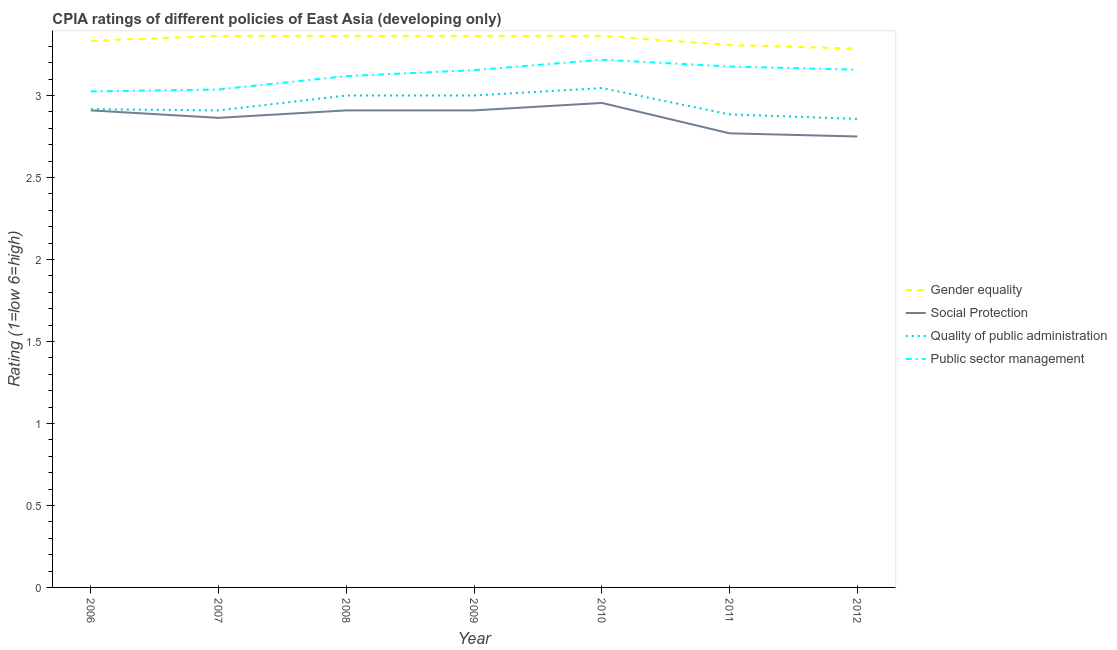Does the line corresponding to cpia rating of social protection intersect with the line corresponding to cpia rating of public sector management?
Your answer should be compact. No. Is the number of lines equal to the number of legend labels?
Your answer should be compact. Yes. What is the cpia rating of social protection in 2010?
Give a very brief answer. 2.95. Across all years, what is the maximum cpia rating of gender equality?
Offer a very short reply. 3.36. Across all years, what is the minimum cpia rating of social protection?
Provide a short and direct response. 2.75. What is the total cpia rating of public sector management in the graph?
Provide a succinct answer. 21.89. What is the difference between the cpia rating of public sector management in 2010 and that in 2012?
Your response must be concise. 0.06. What is the difference between the cpia rating of public sector management in 2006 and the cpia rating of quality of public administration in 2010?
Give a very brief answer. -0.02. What is the average cpia rating of social protection per year?
Make the answer very short. 2.87. In the year 2012, what is the difference between the cpia rating of public sector management and cpia rating of social protection?
Your response must be concise. 0.41. What is the ratio of the cpia rating of social protection in 2010 to that in 2012?
Your response must be concise. 1.07. What is the difference between the highest and the second highest cpia rating of quality of public administration?
Give a very brief answer. 0.05. What is the difference between the highest and the lowest cpia rating of gender equality?
Keep it short and to the point. 0.08. In how many years, is the cpia rating of gender equality greater than the average cpia rating of gender equality taken over all years?
Your response must be concise. 4. Is the sum of the cpia rating of gender equality in 2006 and 2010 greater than the maximum cpia rating of quality of public administration across all years?
Ensure brevity in your answer.  Yes. Is it the case that in every year, the sum of the cpia rating of social protection and cpia rating of public sector management is greater than the sum of cpia rating of gender equality and cpia rating of quality of public administration?
Keep it short and to the point. No. Is the cpia rating of gender equality strictly greater than the cpia rating of public sector management over the years?
Keep it short and to the point. Yes. How many lines are there?
Offer a terse response. 4. Where does the legend appear in the graph?
Give a very brief answer. Center right. What is the title of the graph?
Ensure brevity in your answer.  CPIA ratings of different policies of East Asia (developing only). Does "Efficiency of custom clearance process" appear as one of the legend labels in the graph?
Provide a short and direct response. No. What is the label or title of the X-axis?
Your answer should be compact. Year. What is the label or title of the Y-axis?
Offer a terse response. Rating (1=low 6=high). What is the Rating (1=low 6=high) of Gender equality in 2006?
Provide a succinct answer. 3.33. What is the Rating (1=low 6=high) in Social Protection in 2006?
Offer a very short reply. 2.91. What is the Rating (1=low 6=high) in Quality of public administration in 2006?
Provide a short and direct response. 2.92. What is the Rating (1=low 6=high) in Public sector management in 2006?
Your answer should be compact. 3.02. What is the Rating (1=low 6=high) of Gender equality in 2007?
Your answer should be compact. 3.36. What is the Rating (1=low 6=high) of Social Protection in 2007?
Offer a terse response. 2.86. What is the Rating (1=low 6=high) of Quality of public administration in 2007?
Keep it short and to the point. 2.91. What is the Rating (1=low 6=high) of Public sector management in 2007?
Keep it short and to the point. 3.04. What is the Rating (1=low 6=high) of Gender equality in 2008?
Give a very brief answer. 3.36. What is the Rating (1=low 6=high) in Social Protection in 2008?
Provide a short and direct response. 2.91. What is the Rating (1=low 6=high) in Public sector management in 2008?
Ensure brevity in your answer.  3.12. What is the Rating (1=low 6=high) in Gender equality in 2009?
Make the answer very short. 3.36. What is the Rating (1=low 6=high) in Social Protection in 2009?
Offer a terse response. 2.91. What is the Rating (1=low 6=high) in Public sector management in 2009?
Provide a succinct answer. 3.15. What is the Rating (1=low 6=high) of Gender equality in 2010?
Provide a short and direct response. 3.36. What is the Rating (1=low 6=high) in Social Protection in 2010?
Provide a short and direct response. 2.95. What is the Rating (1=low 6=high) in Quality of public administration in 2010?
Ensure brevity in your answer.  3.05. What is the Rating (1=low 6=high) of Public sector management in 2010?
Make the answer very short. 3.22. What is the Rating (1=low 6=high) of Gender equality in 2011?
Give a very brief answer. 3.31. What is the Rating (1=low 6=high) in Social Protection in 2011?
Offer a very short reply. 2.77. What is the Rating (1=low 6=high) of Quality of public administration in 2011?
Provide a succinct answer. 2.88. What is the Rating (1=low 6=high) of Public sector management in 2011?
Provide a succinct answer. 3.18. What is the Rating (1=low 6=high) in Gender equality in 2012?
Give a very brief answer. 3.29. What is the Rating (1=low 6=high) in Social Protection in 2012?
Give a very brief answer. 2.75. What is the Rating (1=low 6=high) in Quality of public administration in 2012?
Your answer should be very brief. 2.86. What is the Rating (1=low 6=high) in Public sector management in 2012?
Your answer should be very brief. 3.16. Across all years, what is the maximum Rating (1=low 6=high) in Gender equality?
Provide a short and direct response. 3.36. Across all years, what is the maximum Rating (1=low 6=high) of Social Protection?
Your response must be concise. 2.95. Across all years, what is the maximum Rating (1=low 6=high) in Quality of public administration?
Offer a terse response. 3.05. Across all years, what is the maximum Rating (1=low 6=high) of Public sector management?
Offer a terse response. 3.22. Across all years, what is the minimum Rating (1=low 6=high) of Gender equality?
Your answer should be compact. 3.29. Across all years, what is the minimum Rating (1=low 6=high) in Social Protection?
Offer a very short reply. 2.75. Across all years, what is the minimum Rating (1=low 6=high) in Quality of public administration?
Provide a succinct answer. 2.86. Across all years, what is the minimum Rating (1=low 6=high) in Public sector management?
Make the answer very short. 3.02. What is the total Rating (1=low 6=high) in Gender equality in the graph?
Your answer should be compact. 23.38. What is the total Rating (1=low 6=high) of Social Protection in the graph?
Ensure brevity in your answer.  20.06. What is the total Rating (1=low 6=high) in Quality of public administration in the graph?
Make the answer very short. 20.61. What is the total Rating (1=low 6=high) of Public sector management in the graph?
Keep it short and to the point. 21.89. What is the difference between the Rating (1=low 6=high) of Gender equality in 2006 and that in 2007?
Your answer should be very brief. -0.03. What is the difference between the Rating (1=low 6=high) in Social Protection in 2006 and that in 2007?
Keep it short and to the point. 0.05. What is the difference between the Rating (1=low 6=high) in Quality of public administration in 2006 and that in 2007?
Provide a succinct answer. 0.01. What is the difference between the Rating (1=low 6=high) of Public sector management in 2006 and that in 2007?
Keep it short and to the point. -0.01. What is the difference between the Rating (1=low 6=high) of Gender equality in 2006 and that in 2008?
Ensure brevity in your answer.  -0.03. What is the difference between the Rating (1=low 6=high) in Quality of public administration in 2006 and that in 2008?
Your response must be concise. -0.08. What is the difference between the Rating (1=low 6=high) of Public sector management in 2006 and that in 2008?
Your answer should be very brief. -0.09. What is the difference between the Rating (1=low 6=high) of Gender equality in 2006 and that in 2009?
Offer a terse response. -0.03. What is the difference between the Rating (1=low 6=high) in Social Protection in 2006 and that in 2009?
Provide a short and direct response. 0. What is the difference between the Rating (1=low 6=high) in Quality of public administration in 2006 and that in 2009?
Your answer should be very brief. -0.08. What is the difference between the Rating (1=low 6=high) of Public sector management in 2006 and that in 2009?
Give a very brief answer. -0.13. What is the difference between the Rating (1=low 6=high) of Gender equality in 2006 and that in 2010?
Offer a very short reply. -0.03. What is the difference between the Rating (1=low 6=high) in Social Protection in 2006 and that in 2010?
Keep it short and to the point. -0.05. What is the difference between the Rating (1=low 6=high) in Quality of public administration in 2006 and that in 2010?
Keep it short and to the point. -0.13. What is the difference between the Rating (1=low 6=high) in Public sector management in 2006 and that in 2010?
Your answer should be compact. -0.19. What is the difference between the Rating (1=low 6=high) of Gender equality in 2006 and that in 2011?
Ensure brevity in your answer.  0.03. What is the difference between the Rating (1=low 6=high) in Social Protection in 2006 and that in 2011?
Offer a very short reply. 0.14. What is the difference between the Rating (1=low 6=high) in Quality of public administration in 2006 and that in 2011?
Keep it short and to the point. 0.03. What is the difference between the Rating (1=low 6=high) of Public sector management in 2006 and that in 2011?
Your answer should be very brief. -0.15. What is the difference between the Rating (1=low 6=high) in Gender equality in 2006 and that in 2012?
Provide a succinct answer. 0.05. What is the difference between the Rating (1=low 6=high) of Social Protection in 2006 and that in 2012?
Provide a short and direct response. 0.16. What is the difference between the Rating (1=low 6=high) in Quality of public administration in 2006 and that in 2012?
Your answer should be very brief. 0.06. What is the difference between the Rating (1=low 6=high) in Public sector management in 2006 and that in 2012?
Provide a succinct answer. -0.13. What is the difference between the Rating (1=low 6=high) in Gender equality in 2007 and that in 2008?
Your answer should be very brief. 0. What is the difference between the Rating (1=low 6=high) in Social Protection in 2007 and that in 2008?
Provide a succinct answer. -0.05. What is the difference between the Rating (1=low 6=high) of Quality of public administration in 2007 and that in 2008?
Provide a succinct answer. -0.09. What is the difference between the Rating (1=low 6=high) of Public sector management in 2007 and that in 2008?
Make the answer very short. -0.08. What is the difference between the Rating (1=low 6=high) of Gender equality in 2007 and that in 2009?
Provide a short and direct response. 0. What is the difference between the Rating (1=low 6=high) in Social Protection in 2007 and that in 2009?
Your answer should be very brief. -0.05. What is the difference between the Rating (1=low 6=high) in Quality of public administration in 2007 and that in 2009?
Keep it short and to the point. -0.09. What is the difference between the Rating (1=low 6=high) in Public sector management in 2007 and that in 2009?
Your response must be concise. -0.12. What is the difference between the Rating (1=low 6=high) of Gender equality in 2007 and that in 2010?
Keep it short and to the point. 0. What is the difference between the Rating (1=low 6=high) in Social Protection in 2007 and that in 2010?
Provide a short and direct response. -0.09. What is the difference between the Rating (1=low 6=high) of Quality of public administration in 2007 and that in 2010?
Keep it short and to the point. -0.14. What is the difference between the Rating (1=low 6=high) in Public sector management in 2007 and that in 2010?
Provide a succinct answer. -0.18. What is the difference between the Rating (1=low 6=high) in Gender equality in 2007 and that in 2011?
Provide a succinct answer. 0.06. What is the difference between the Rating (1=low 6=high) of Social Protection in 2007 and that in 2011?
Keep it short and to the point. 0.09. What is the difference between the Rating (1=low 6=high) of Quality of public administration in 2007 and that in 2011?
Give a very brief answer. 0.02. What is the difference between the Rating (1=low 6=high) of Public sector management in 2007 and that in 2011?
Your response must be concise. -0.14. What is the difference between the Rating (1=low 6=high) of Gender equality in 2007 and that in 2012?
Give a very brief answer. 0.08. What is the difference between the Rating (1=low 6=high) of Social Protection in 2007 and that in 2012?
Make the answer very short. 0.11. What is the difference between the Rating (1=low 6=high) in Quality of public administration in 2007 and that in 2012?
Your response must be concise. 0.05. What is the difference between the Rating (1=low 6=high) in Public sector management in 2007 and that in 2012?
Your response must be concise. -0.12. What is the difference between the Rating (1=low 6=high) of Public sector management in 2008 and that in 2009?
Provide a short and direct response. -0.04. What is the difference between the Rating (1=low 6=high) in Gender equality in 2008 and that in 2010?
Provide a succinct answer. 0. What is the difference between the Rating (1=low 6=high) of Social Protection in 2008 and that in 2010?
Provide a short and direct response. -0.05. What is the difference between the Rating (1=low 6=high) of Quality of public administration in 2008 and that in 2010?
Provide a short and direct response. -0.05. What is the difference between the Rating (1=low 6=high) of Public sector management in 2008 and that in 2010?
Provide a succinct answer. -0.1. What is the difference between the Rating (1=low 6=high) of Gender equality in 2008 and that in 2011?
Your answer should be compact. 0.06. What is the difference between the Rating (1=low 6=high) of Social Protection in 2008 and that in 2011?
Ensure brevity in your answer.  0.14. What is the difference between the Rating (1=low 6=high) in Quality of public administration in 2008 and that in 2011?
Provide a succinct answer. 0.12. What is the difference between the Rating (1=low 6=high) of Public sector management in 2008 and that in 2011?
Give a very brief answer. -0.06. What is the difference between the Rating (1=low 6=high) of Gender equality in 2008 and that in 2012?
Your answer should be very brief. 0.08. What is the difference between the Rating (1=low 6=high) in Social Protection in 2008 and that in 2012?
Keep it short and to the point. 0.16. What is the difference between the Rating (1=low 6=high) of Quality of public administration in 2008 and that in 2012?
Make the answer very short. 0.14. What is the difference between the Rating (1=low 6=high) of Public sector management in 2008 and that in 2012?
Provide a succinct answer. -0.04. What is the difference between the Rating (1=low 6=high) of Social Protection in 2009 and that in 2010?
Offer a terse response. -0.05. What is the difference between the Rating (1=low 6=high) in Quality of public administration in 2009 and that in 2010?
Give a very brief answer. -0.05. What is the difference between the Rating (1=low 6=high) of Public sector management in 2009 and that in 2010?
Give a very brief answer. -0.06. What is the difference between the Rating (1=low 6=high) of Gender equality in 2009 and that in 2011?
Offer a terse response. 0.06. What is the difference between the Rating (1=low 6=high) in Social Protection in 2009 and that in 2011?
Your answer should be compact. 0.14. What is the difference between the Rating (1=low 6=high) of Quality of public administration in 2009 and that in 2011?
Your answer should be very brief. 0.12. What is the difference between the Rating (1=low 6=high) of Public sector management in 2009 and that in 2011?
Provide a succinct answer. -0.02. What is the difference between the Rating (1=low 6=high) in Gender equality in 2009 and that in 2012?
Offer a terse response. 0.08. What is the difference between the Rating (1=low 6=high) in Social Protection in 2009 and that in 2012?
Make the answer very short. 0.16. What is the difference between the Rating (1=low 6=high) of Quality of public administration in 2009 and that in 2012?
Ensure brevity in your answer.  0.14. What is the difference between the Rating (1=low 6=high) of Public sector management in 2009 and that in 2012?
Your response must be concise. -0. What is the difference between the Rating (1=low 6=high) of Gender equality in 2010 and that in 2011?
Give a very brief answer. 0.06. What is the difference between the Rating (1=low 6=high) of Social Protection in 2010 and that in 2011?
Offer a very short reply. 0.19. What is the difference between the Rating (1=low 6=high) in Quality of public administration in 2010 and that in 2011?
Your response must be concise. 0.16. What is the difference between the Rating (1=low 6=high) of Public sector management in 2010 and that in 2011?
Your response must be concise. 0.04. What is the difference between the Rating (1=low 6=high) of Gender equality in 2010 and that in 2012?
Give a very brief answer. 0.08. What is the difference between the Rating (1=low 6=high) in Social Protection in 2010 and that in 2012?
Offer a very short reply. 0.2. What is the difference between the Rating (1=low 6=high) of Quality of public administration in 2010 and that in 2012?
Make the answer very short. 0.19. What is the difference between the Rating (1=low 6=high) in Public sector management in 2010 and that in 2012?
Provide a succinct answer. 0.06. What is the difference between the Rating (1=low 6=high) in Gender equality in 2011 and that in 2012?
Your answer should be compact. 0.02. What is the difference between the Rating (1=low 6=high) in Social Protection in 2011 and that in 2012?
Your response must be concise. 0.02. What is the difference between the Rating (1=low 6=high) of Quality of public administration in 2011 and that in 2012?
Keep it short and to the point. 0.03. What is the difference between the Rating (1=low 6=high) of Public sector management in 2011 and that in 2012?
Provide a succinct answer. 0.02. What is the difference between the Rating (1=low 6=high) in Gender equality in 2006 and the Rating (1=low 6=high) in Social Protection in 2007?
Your answer should be compact. 0.47. What is the difference between the Rating (1=low 6=high) in Gender equality in 2006 and the Rating (1=low 6=high) in Quality of public administration in 2007?
Ensure brevity in your answer.  0.42. What is the difference between the Rating (1=low 6=high) of Gender equality in 2006 and the Rating (1=low 6=high) of Public sector management in 2007?
Ensure brevity in your answer.  0.3. What is the difference between the Rating (1=low 6=high) of Social Protection in 2006 and the Rating (1=low 6=high) of Quality of public administration in 2007?
Make the answer very short. 0. What is the difference between the Rating (1=low 6=high) of Social Protection in 2006 and the Rating (1=low 6=high) of Public sector management in 2007?
Keep it short and to the point. -0.13. What is the difference between the Rating (1=low 6=high) of Quality of public administration in 2006 and the Rating (1=low 6=high) of Public sector management in 2007?
Offer a terse response. -0.12. What is the difference between the Rating (1=low 6=high) of Gender equality in 2006 and the Rating (1=low 6=high) of Social Protection in 2008?
Offer a very short reply. 0.42. What is the difference between the Rating (1=low 6=high) in Gender equality in 2006 and the Rating (1=low 6=high) in Quality of public administration in 2008?
Make the answer very short. 0.33. What is the difference between the Rating (1=low 6=high) in Gender equality in 2006 and the Rating (1=low 6=high) in Public sector management in 2008?
Provide a succinct answer. 0.22. What is the difference between the Rating (1=low 6=high) in Social Protection in 2006 and the Rating (1=low 6=high) in Quality of public administration in 2008?
Ensure brevity in your answer.  -0.09. What is the difference between the Rating (1=low 6=high) of Social Protection in 2006 and the Rating (1=low 6=high) of Public sector management in 2008?
Give a very brief answer. -0.21. What is the difference between the Rating (1=low 6=high) of Quality of public administration in 2006 and the Rating (1=low 6=high) of Public sector management in 2008?
Keep it short and to the point. -0.2. What is the difference between the Rating (1=low 6=high) in Gender equality in 2006 and the Rating (1=low 6=high) in Social Protection in 2009?
Your response must be concise. 0.42. What is the difference between the Rating (1=low 6=high) in Gender equality in 2006 and the Rating (1=low 6=high) in Quality of public administration in 2009?
Keep it short and to the point. 0.33. What is the difference between the Rating (1=low 6=high) of Gender equality in 2006 and the Rating (1=low 6=high) of Public sector management in 2009?
Ensure brevity in your answer.  0.18. What is the difference between the Rating (1=low 6=high) of Social Protection in 2006 and the Rating (1=low 6=high) of Quality of public administration in 2009?
Offer a terse response. -0.09. What is the difference between the Rating (1=low 6=high) in Social Protection in 2006 and the Rating (1=low 6=high) in Public sector management in 2009?
Your answer should be very brief. -0.25. What is the difference between the Rating (1=low 6=high) in Quality of public administration in 2006 and the Rating (1=low 6=high) in Public sector management in 2009?
Keep it short and to the point. -0.24. What is the difference between the Rating (1=low 6=high) in Gender equality in 2006 and the Rating (1=low 6=high) in Social Protection in 2010?
Make the answer very short. 0.38. What is the difference between the Rating (1=low 6=high) of Gender equality in 2006 and the Rating (1=low 6=high) of Quality of public administration in 2010?
Your response must be concise. 0.29. What is the difference between the Rating (1=low 6=high) of Gender equality in 2006 and the Rating (1=low 6=high) of Public sector management in 2010?
Provide a succinct answer. 0.12. What is the difference between the Rating (1=low 6=high) in Social Protection in 2006 and the Rating (1=low 6=high) in Quality of public administration in 2010?
Provide a short and direct response. -0.14. What is the difference between the Rating (1=low 6=high) in Social Protection in 2006 and the Rating (1=low 6=high) in Public sector management in 2010?
Your answer should be compact. -0.31. What is the difference between the Rating (1=low 6=high) of Quality of public administration in 2006 and the Rating (1=low 6=high) of Public sector management in 2010?
Make the answer very short. -0.3. What is the difference between the Rating (1=low 6=high) in Gender equality in 2006 and the Rating (1=low 6=high) in Social Protection in 2011?
Offer a terse response. 0.56. What is the difference between the Rating (1=low 6=high) of Gender equality in 2006 and the Rating (1=low 6=high) of Quality of public administration in 2011?
Give a very brief answer. 0.45. What is the difference between the Rating (1=low 6=high) of Gender equality in 2006 and the Rating (1=low 6=high) of Public sector management in 2011?
Keep it short and to the point. 0.16. What is the difference between the Rating (1=low 6=high) of Social Protection in 2006 and the Rating (1=low 6=high) of Quality of public administration in 2011?
Make the answer very short. 0.02. What is the difference between the Rating (1=low 6=high) in Social Protection in 2006 and the Rating (1=low 6=high) in Public sector management in 2011?
Ensure brevity in your answer.  -0.27. What is the difference between the Rating (1=low 6=high) of Quality of public administration in 2006 and the Rating (1=low 6=high) of Public sector management in 2011?
Provide a succinct answer. -0.26. What is the difference between the Rating (1=low 6=high) of Gender equality in 2006 and the Rating (1=low 6=high) of Social Protection in 2012?
Ensure brevity in your answer.  0.58. What is the difference between the Rating (1=low 6=high) of Gender equality in 2006 and the Rating (1=low 6=high) of Quality of public administration in 2012?
Offer a terse response. 0.48. What is the difference between the Rating (1=low 6=high) in Gender equality in 2006 and the Rating (1=low 6=high) in Public sector management in 2012?
Your answer should be very brief. 0.18. What is the difference between the Rating (1=low 6=high) of Social Protection in 2006 and the Rating (1=low 6=high) of Quality of public administration in 2012?
Provide a succinct answer. 0.05. What is the difference between the Rating (1=low 6=high) of Social Protection in 2006 and the Rating (1=low 6=high) of Public sector management in 2012?
Give a very brief answer. -0.25. What is the difference between the Rating (1=low 6=high) of Quality of public administration in 2006 and the Rating (1=low 6=high) of Public sector management in 2012?
Your answer should be very brief. -0.24. What is the difference between the Rating (1=low 6=high) of Gender equality in 2007 and the Rating (1=low 6=high) of Social Protection in 2008?
Your answer should be very brief. 0.45. What is the difference between the Rating (1=low 6=high) of Gender equality in 2007 and the Rating (1=low 6=high) of Quality of public administration in 2008?
Provide a succinct answer. 0.36. What is the difference between the Rating (1=low 6=high) in Gender equality in 2007 and the Rating (1=low 6=high) in Public sector management in 2008?
Give a very brief answer. 0.25. What is the difference between the Rating (1=low 6=high) of Social Protection in 2007 and the Rating (1=low 6=high) of Quality of public administration in 2008?
Make the answer very short. -0.14. What is the difference between the Rating (1=low 6=high) in Social Protection in 2007 and the Rating (1=low 6=high) in Public sector management in 2008?
Ensure brevity in your answer.  -0.25. What is the difference between the Rating (1=low 6=high) in Quality of public administration in 2007 and the Rating (1=low 6=high) in Public sector management in 2008?
Offer a terse response. -0.21. What is the difference between the Rating (1=low 6=high) of Gender equality in 2007 and the Rating (1=low 6=high) of Social Protection in 2009?
Your answer should be very brief. 0.45. What is the difference between the Rating (1=low 6=high) of Gender equality in 2007 and the Rating (1=low 6=high) of Quality of public administration in 2009?
Keep it short and to the point. 0.36. What is the difference between the Rating (1=low 6=high) in Gender equality in 2007 and the Rating (1=low 6=high) in Public sector management in 2009?
Give a very brief answer. 0.21. What is the difference between the Rating (1=low 6=high) of Social Protection in 2007 and the Rating (1=low 6=high) of Quality of public administration in 2009?
Make the answer very short. -0.14. What is the difference between the Rating (1=low 6=high) of Social Protection in 2007 and the Rating (1=low 6=high) of Public sector management in 2009?
Give a very brief answer. -0.29. What is the difference between the Rating (1=low 6=high) in Quality of public administration in 2007 and the Rating (1=low 6=high) in Public sector management in 2009?
Offer a very short reply. -0.25. What is the difference between the Rating (1=low 6=high) of Gender equality in 2007 and the Rating (1=low 6=high) of Social Protection in 2010?
Your answer should be compact. 0.41. What is the difference between the Rating (1=low 6=high) in Gender equality in 2007 and the Rating (1=low 6=high) in Quality of public administration in 2010?
Your answer should be compact. 0.32. What is the difference between the Rating (1=low 6=high) of Gender equality in 2007 and the Rating (1=low 6=high) of Public sector management in 2010?
Provide a short and direct response. 0.15. What is the difference between the Rating (1=low 6=high) of Social Protection in 2007 and the Rating (1=low 6=high) of Quality of public administration in 2010?
Provide a succinct answer. -0.18. What is the difference between the Rating (1=low 6=high) in Social Protection in 2007 and the Rating (1=low 6=high) in Public sector management in 2010?
Your answer should be compact. -0.35. What is the difference between the Rating (1=low 6=high) in Quality of public administration in 2007 and the Rating (1=low 6=high) in Public sector management in 2010?
Provide a short and direct response. -0.31. What is the difference between the Rating (1=low 6=high) of Gender equality in 2007 and the Rating (1=low 6=high) of Social Protection in 2011?
Ensure brevity in your answer.  0.59. What is the difference between the Rating (1=low 6=high) of Gender equality in 2007 and the Rating (1=low 6=high) of Quality of public administration in 2011?
Offer a terse response. 0.48. What is the difference between the Rating (1=low 6=high) in Gender equality in 2007 and the Rating (1=low 6=high) in Public sector management in 2011?
Make the answer very short. 0.19. What is the difference between the Rating (1=low 6=high) of Social Protection in 2007 and the Rating (1=low 6=high) of Quality of public administration in 2011?
Provide a succinct answer. -0.02. What is the difference between the Rating (1=low 6=high) in Social Protection in 2007 and the Rating (1=low 6=high) in Public sector management in 2011?
Ensure brevity in your answer.  -0.31. What is the difference between the Rating (1=low 6=high) of Quality of public administration in 2007 and the Rating (1=low 6=high) of Public sector management in 2011?
Offer a terse response. -0.27. What is the difference between the Rating (1=low 6=high) of Gender equality in 2007 and the Rating (1=low 6=high) of Social Protection in 2012?
Your answer should be very brief. 0.61. What is the difference between the Rating (1=low 6=high) in Gender equality in 2007 and the Rating (1=low 6=high) in Quality of public administration in 2012?
Ensure brevity in your answer.  0.51. What is the difference between the Rating (1=low 6=high) in Gender equality in 2007 and the Rating (1=low 6=high) in Public sector management in 2012?
Offer a terse response. 0.21. What is the difference between the Rating (1=low 6=high) of Social Protection in 2007 and the Rating (1=low 6=high) of Quality of public administration in 2012?
Provide a short and direct response. 0.01. What is the difference between the Rating (1=low 6=high) of Social Protection in 2007 and the Rating (1=low 6=high) of Public sector management in 2012?
Ensure brevity in your answer.  -0.29. What is the difference between the Rating (1=low 6=high) in Quality of public administration in 2007 and the Rating (1=low 6=high) in Public sector management in 2012?
Make the answer very short. -0.25. What is the difference between the Rating (1=low 6=high) in Gender equality in 2008 and the Rating (1=low 6=high) in Social Protection in 2009?
Your answer should be compact. 0.45. What is the difference between the Rating (1=low 6=high) of Gender equality in 2008 and the Rating (1=low 6=high) of Quality of public administration in 2009?
Provide a short and direct response. 0.36. What is the difference between the Rating (1=low 6=high) in Gender equality in 2008 and the Rating (1=low 6=high) in Public sector management in 2009?
Give a very brief answer. 0.21. What is the difference between the Rating (1=low 6=high) of Social Protection in 2008 and the Rating (1=low 6=high) of Quality of public administration in 2009?
Ensure brevity in your answer.  -0.09. What is the difference between the Rating (1=low 6=high) of Social Protection in 2008 and the Rating (1=low 6=high) of Public sector management in 2009?
Give a very brief answer. -0.25. What is the difference between the Rating (1=low 6=high) in Quality of public administration in 2008 and the Rating (1=low 6=high) in Public sector management in 2009?
Provide a succinct answer. -0.15. What is the difference between the Rating (1=low 6=high) in Gender equality in 2008 and the Rating (1=low 6=high) in Social Protection in 2010?
Make the answer very short. 0.41. What is the difference between the Rating (1=low 6=high) in Gender equality in 2008 and the Rating (1=low 6=high) in Quality of public administration in 2010?
Offer a very short reply. 0.32. What is the difference between the Rating (1=low 6=high) of Gender equality in 2008 and the Rating (1=low 6=high) of Public sector management in 2010?
Provide a short and direct response. 0.15. What is the difference between the Rating (1=low 6=high) of Social Protection in 2008 and the Rating (1=low 6=high) of Quality of public administration in 2010?
Your answer should be compact. -0.14. What is the difference between the Rating (1=low 6=high) of Social Protection in 2008 and the Rating (1=low 6=high) of Public sector management in 2010?
Your answer should be very brief. -0.31. What is the difference between the Rating (1=low 6=high) of Quality of public administration in 2008 and the Rating (1=low 6=high) of Public sector management in 2010?
Ensure brevity in your answer.  -0.22. What is the difference between the Rating (1=low 6=high) in Gender equality in 2008 and the Rating (1=low 6=high) in Social Protection in 2011?
Provide a short and direct response. 0.59. What is the difference between the Rating (1=low 6=high) in Gender equality in 2008 and the Rating (1=low 6=high) in Quality of public administration in 2011?
Provide a succinct answer. 0.48. What is the difference between the Rating (1=low 6=high) of Gender equality in 2008 and the Rating (1=low 6=high) of Public sector management in 2011?
Make the answer very short. 0.19. What is the difference between the Rating (1=low 6=high) of Social Protection in 2008 and the Rating (1=low 6=high) of Quality of public administration in 2011?
Your answer should be very brief. 0.02. What is the difference between the Rating (1=low 6=high) of Social Protection in 2008 and the Rating (1=low 6=high) of Public sector management in 2011?
Your answer should be very brief. -0.27. What is the difference between the Rating (1=low 6=high) in Quality of public administration in 2008 and the Rating (1=low 6=high) in Public sector management in 2011?
Your response must be concise. -0.18. What is the difference between the Rating (1=low 6=high) of Gender equality in 2008 and the Rating (1=low 6=high) of Social Protection in 2012?
Make the answer very short. 0.61. What is the difference between the Rating (1=low 6=high) of Gender equality in 2008 and the Rating (1=low 6=high) of Quality of public administration in 2012?
Keep it short and to the point. 0.51. What is the difference between the Rating (1=low 6=high) of Gender equality in 2008 and the Rating (1=low 6=high) of Public sector management in 2012?
Your answer should be very brief. 0.21. What is the difference between the Rating (1=low 6=high) in Social Protection in 2008 and the Rating (1=low 6=high) in Quality of public administration in 2012?
Ensure brevity in your answer.  0.05. What is the difference between the Rating (1=low 6=high) of Social Protection in 2008 and the Rating (1=low 6=high) of Public sector management in 2012?
Make the answer very short. -0.25. What is the difference between the Rating (1=low 6=high) in Quality of public administration in 2008 and the Rating (1=low 6=high) in Public sector management in 2012?
Keep it short and to the point. -0.16. What is the difference between the Rating (1=low 6=high) in Gender equality in 2009 and the Rating (1=low 6=high) in Social Protection in 2010?
Provide a short and direct response. 0.41. What is the difference between the Rating (1=low 6=high) in Gender equality in 2009 and the Rating (1=low 6=high) in Quality of public administration in 2010?
Make the answer very short. 0.32. What is the difference between the Rating (1=low 6=high) of Gender equality in 2009 and the Rating (1=low 6=high) of Public sector management in 2010?
Provide a short and direct response. 0.15. What is the difference between the Rating (1=low 6=high) of Social Protection in 2009 and the Rating (1=low 6=high) of Quality of public administration in 2010?
Your response must be concise. -0.14. What is the difference between the Rating (1=low 6=high) of Social Protection in 2009 and the Rating (1=low 6=high) of Public sector management in 2010?
Make the answer very short. -0.31. What is the difference between the Rating (1=low 6=high) of Quality of public administration in 2009 and the Rating (1=low 6=high) of Public sector management in 2010?
Your answer should be very brief. -0.22. What is the difference between the Rating (1=low 6=high) of Gender equality in 2009 and the Rating (1=low 6=high) of Social Protection in 2011?
Your answer should be compact. 0.59. What is the difference between the Rating (1=low 6=high) in Gender equality in 2009 and the Rating (1=low 6=high) in Quality of public administration in 2011?
Your answer should be compact. 0.48. What is the difference between the Rating (1=low 6=high) in Gender equality in 2009 and the Rating (1=low 6=high) in Public sector management in 2011?
Give a very brief answer. 0.19. What is the difference between the Rating (1=low 6=high) of Social Protection in 2009 and the Rating (1=low 6=high) of Quality of public administration in 2011?
Give a very brief answer. 0.02. What is the difference between the Rating (1=low 6=high) of Social Protection in 2009 and the Rating (1=low 6=high) of Public sector management in 2011?
Offer a very short reply. -0.27. What is the difference between the Rating (1=low 6=high) in Quality of public administration in 2009 and the Rating (1=low 6=high) in Public sector management in 2011?
Your response must be concise. -0.18. What is the difference between the Rating (1=low 6=high) in Gender equality in 2009 and the Rating (1=low 6=high) in Social Protection in 2012?
Provide a succinct answer. 0.61. What is the difference between the Rating (1=low 6=high) of Gender equality in 2009 and the Rating (1=low 6=high) of Quality of public administration in 2012?
Provide a succinct answer. 0.51. What is the difference between the Rating (1=low 6=high) of Gender equality in 2009 and the Rating (1=low 6=high) of Public sector management in 2012?
Your answer should be compact. 0.21. What is the difference between the Rating (1=low 6=high) of Social Protection in 2009 and the Rating (1=low 6=high) of Quality of public administration in 2012?
Make the answer very short. 0.05. What is the difference between the Rating (1=low 6=high) in Social Protection in 2009 and the Rating (1=low 6=high) in Public sector management in 2012?
Your answer should be compact. -0.25. What is the difference between the Rating (1=low 6=high) in Quality of public administration in 2009 and the Rating (1=low 6=high) in Public sector management in 2012?
Provide a succinct answer. -0.16. What is the difference between the Rating (1=low 6=high) in Gender equality in 2010 and the Rating (1=low 6=high) in Social Protection in 2011?
Provide a short and direct response. 0.59. What is the difference between the Rating (1=low 6=high) in Gender equality in 2010 and the Rating (1=low 6=high) in Quality of public administration in 2011?
Give a very brief answer. 0.48. What is the difference between the Rating (1=low 6=high) in Gender equality in 2010 and the Rating (1=low 6=high) in Public sector management in 2011?
Your answer should be very brief. 0.19. What is the difference between the Rating (1=low 6=high) in Social Protection in 2010 and the Rating (1=low 6=high) in Quality of public administration in 2011?
Your response must be concise. 0.07. What is the difference between the Rating (1=low 6=high) in Social Protection in 2010 and the Rating (1=low 6=high) in Public sector management in 2011?
Provide a short and direct response. -0.22. What is the difference between the Rating (1=low 6=high) in Quality of public administration in 2010 and the Rating (1=low 6=high) in Public sector management in 2011?
Your response must be concise. -0.13. What is the difference between the Rating (1=low 6=high) of Gender equality in 2010 and the Rating (1=low 6=high) of Social Protection in 2012?
Give a very brief answer. 0.61. What is the difference between the Rating (1=low 6=high) in Gender equality in 2010 and the Rating (1=low 6=high) in Quality of public administration in 2012?
Make the answer very short. 0.51. What is the difference between the Rating (1=low 6=high) in Gender equality in 2010 and the Rating (1=low 6=high) in Public sector management in 2012?
Ensure brevity in your answer.  0.21. What is the difference between the Rating (1=low 6=high) of Social Protection in 2010 and the Rating (1=low 6=high) of Quality of public administration in 2012?
Ensure brevity in your answer.  0.1. What is the difference between the Rating (1=low 6=high) of Social Protection in 2010 and the Rating (1=low 6=high) of Public sector management in 2012?
Give a very brief answer. -0.2. What is the difference between the Rating (1=low 6=high) in Quality of public administration in 2010 and the Rating (1=low 6=high) in Public sector management in 2012?
Offer a very short reply. -0.11. What is the difference between the Rating (1=low 6=high) in Gender equality in 2011 and the Rating (1=low 6=high) in Social Protection in 2012?
Ensure brevity in your answer.  0.56. What is the difference between the Rating (1=low 6=high) of Gender equality in 2011 and the Rating (1=low 6=high) of Quality of public administration in 2012?
Give a very brief answer. 0.45. What is the difference between the Rating (1=low 6=high) of Gender equality in 2011 and the Rating (1=low 6=high) of Public sector management in 2012?
Offer a very short reply. 0.15. What is the difference between the Rating (1=low 6=high) in Social Protection in 2011 and the Rating (1=low 6=high) in Quality of public administration in 2012?
Ensure brevity in your answer.  -0.09. What is the difference between the Rating (1=low 6=high) in Social Protection in 2011 and the Rating (1=low 6=high) in Public sector management in 2012?
Offer a very short reply. -0.39. What is the difference between the Rating (1=low 6=high) of Quality of public administration in 2011 and the Rating (1=low 6=high) of Public sector management in 2012?
Provide a short and direct response. -0.27. What is the average Rating (1=low 6=high) in Gender equality per year?
Ensure brevity in your answer.  3.34. What is the average Rating (1=low 6=high) of Social Protection per year?
Provide a succinct answer. 2.87. What is the average Rating (1=low 6=high) of Quality of public administration per year?
Keep it short and to the point. 2.94. What is the average Rating (1=low 6=high) in Public sector management per year?
Provide a succinct answer. 3.13. In the year 2006, what is the difference between the Rating (1=low 6=high) of Gender equality and Rating (1=low 6=high) of Social Protection?
Keep it short and to the point. 0.42. In the year 2006, what is the difference between the Rating (1=low 6=high) of Gender equality and Rating (1=low 6=high) of Quality of public administration?
Make the answer very short. 0.42. In the year 2006, what is the difference between the Rating (1=low 6=high) of Gender equality and Rating (1=low 6=high) of Public sector management?
Your answer should be compact. 0.31. In the year 2006, what is the difference between the Rating (1=low 6=high) of Social Protection and Rating (1=low 6=high) of Quality of public administration?
Offer a terse response. -0.01. In the year 2006, what is the difference between the Rating (1=low 6=high) of Social Protection and Rating (1=low 6=high) of Public sector management?
Provide a short and direct response. -0.12. In the year 2006, what is the difference between the Rating (1=low 6=high) in Quality of public administration and Rating (1=low 6=high) in Public sector management?
Keep it short and to the point. -0.11. In the year 2007, what is the difference between the Rating (1=low 6=high) in Gender equality and Rating (1=low 6=high) in Social Protection?
Offer a very short reply. 0.5. In the year 2007, what is the difference between the Rating (1=low 6=high) of Gender equality and Rating (1=low 6=high) of Quality of public administration?
Offer a terse response. 0.45. In the year 2007, what is the difference between the Rating (1=low 6=high) in Gender equality and Rating (1=low 6=high) in Public sector management?
Offer a terse response. 0.33. In the year 2007, what is the difference between the Rating (1=low 6=high) in Social Protection and Rating (1=low 6=high) in Quality of public administration?
Provide a succinct answer. -0.05. In the year 2007, what is the difference between the Rating (1=low 6=high) in Social Protection and Rating (1=low 6=high) in Public sector management?
Your answer should be very brief. -0.17. In the year 2007, what is the difference between the Rating (1=low 6=high) in Quality of public administration and Rating (1=low 6=high) in Public sector management?
Keep it short and to the point. -0.13. In the year 2008, what is the difference between the Rating (1=low 6=high) in Gender equality and Rating (1=low 6=high) in Social Protection?
Give a very brief answer. 0.45. In the year 2008, what is the difference between the Rating (1=low 6=high) in Gender equality and Rating (1=low 6=high) in Quality of public administration?
Your answer should be very brief. 0.36. In the year 2008, what is the difference between the Rating (1=low 6=high) in Gender equality and Rating (1=low 6=high) in Public sector management?
Provide a short and direct response. 0.25. In the year 2008, what is the difference between the Rating (1=low 6=high) in Social Protection and Rating (1=low 6=high) in Quality of public administration?
Make the answer very short. -0.09. In the year 2008, what is the difference between the Rating (1=low 6=high) of Social Protection and Rating (1=low 6=high) of Public sector management?
Your answer should be compact. -0.21. In the year 2008, what is the difference between the Rating (1=low 6=high) in Quality of public administration and Rating (1=low 6=high) in Public sector management?
Your answer should be very brief. -0.12. In the year 2009, what is the difference between the Rating (1=low 6=high) of Gender equality and Rating (1=low 6=high) of Social Protection?
Your answer should be compact. 0.45. In the year 2009, what is the difference between the Rating (1=low 6=high) in Gender equality and Rating (1=low 6=high) in Quality of public administration?
Provide a succinct answer. 0.36. In the year 2009, what is the difference between the Rating (1=low 6=high) of Gender equality and Rating (1=low 6=high) of Public sector management?
Provide a succinct answer. 0.21. In the year 2009, what is the difference between the Rating (1=low 6=high) of Social Protection and Rating (1=low 6=high) of Quality of public administration?
Keep it short and to the point. -0.09. In the year 2009, what is the difference between the Rating (1=low 6=high) of Social Protection and Rating (1=low 6=high) of Public sector management?
Offer a terse response. -0.25. In the year 2009, what is the difference between the Rating (1=low 6=high) in Quality of public administration and Rating (1=low 6=high) in Public sector management?
Offer a terse response. -0.15. In the year 2010, what is the difference between the Rating (1=low 6=high) in Gender equality and Rating (1=low 6=high) in Social Protection?
Offer a terse response. 0.41. In the year 2010, what is the difference between the Rating (1=low 6=high) of Gender equality and Rating (1=low 6=high) of Quality of public administration?
Give a very brief answer. 0.32. In the year 2010, what is the difference between the Rating (1=low 6=high) of Gender equality and Rating (1=low 6=high) of Public sector management?
Make the answer very short. 0.15. In the year 2010, what is the difference between the Rating (1=low 6=high) of Social Protection and Rating (1=low 6=high) of Quality of public administration?
Offer a terse response. -0.09. In the year 2010, what is the difference between the Rating (1=low 6=high) of Social Protection and Rating (1=low 6=high) of Public sector management?
Keep it short and to the point. -0.26. In the year 2010, what is the difference between the Rating (1=low 6=high) of Quality of public administration and Rating (1=low 6=high) of Public sector management?
Keep it short and to the point. -0.17. In the year 2011, what is the difference between the Rating (1=low 6=high) of Gender equality and Rating (1=low 6=high) of Social Protection?
Your answer should be very brief. 0.54. In the year 2011, what is the difference between the Rating (1=low 6=high) of Gender equality and Rating (1=low 6=high) of Quality of public administration?
Offer a very short reply. 0.42. In the year 2011, what is the difference between the Rating (1=low 6=high) of Gender equality and Rating (1=low 6=high) of Public sector management?
Offer a very short reply. 0.13. In the year 2011, what is the difference between the Rating (1=low 6=high) in Social Protection and Rating (1=low 6=high) in Quality of public administration?
Give a very brief answer. -0.12. In the year 2011, what is the difference between the Rating (1=low 6=high) in Social Protection and Rating (1=low 6=high) in Public sector management?
Provide a succinct answer. -0.41. In the year 2011, what is the difference between the Rating (1=low 6=high) of Quality of public administration and Rating (1=low 6=high) of Public sector management?
Your answer should be very brief. -0.29. In the year 2012, what is the difference between the Rating (1=low 6=high) in Gender equality and Rating (1=low 6=high) in Social Protection?
Provide a short and direct response. 0.54. In the year 2012, what is the difference between the Rating (1=low 6=high) of Gender equality and Rating (1=low 6=high) of Quality of public administration?
Offer a terse response. 0.43. In the year 2012, what is the difference between the Rating (1=low 6=high) in Gender equality and Rating (1=low 6=high) in Public sector management?
Ensure brevity in your answer.  0.13. In the year 2012, what is the difference between the Rating (1=low 6=high) in Social Protection and Rating (1=low 6=high) in Quality of public administration?
Make the answer very short. -0.11. In the year 2012, what is the difference between the Rating (1=low 6=high) of Social Protection and Rating (1=low 6=high) of Public sector management?
Give a very brief answer. -0.41. What is the ratio of the Rating (1=low 6=high) of Gender equality in 2006 to that in 2007?
Keep it short and to the point. 0.99. What is the ratio of the Rating (1=low 6=high) in Social Protection in 2006 to that in 2007?
Offer a terse response. 1.02. What is the ratio of the Rating (1=low 6=high) in Quality of public administration in 2006 to that in 2007?
Your response must be concise. 1. What is the ratio of the Rating (1=low 6=high) of Public sector management in 2006 to that in 2007?
Give a very brief answer. 1. What is the ratio of the Rating (1=low 6=high) of Gender equality in 2006 to that in 2008?
Give a very brief answer. 0.99. What is the ratio of the Rating (1=low 6=high) of Quality of public administration in 2006 to that in 2008?
Your response must be concise. 0.97. What is the ratio of the Rating (1=low 6=high) in Public sector management in 2006 to that in 2008?
Ensure brevity in your answer.  0.97. What is the ratio of the Rating (1=low 6=high) in Gender equality in 2006 to that in 2009?
Your answer should be compact. 0.99. What is the ratio of the Rating (1=low 6=high) of Quality of public administration in 2006 to that in 2009?
Your answer should be very brief. 0.97. What is the ratio of the Rating (1=low 6=high) of Public sector management in 2006 to that in 2009?
Provide a succinct answer. 0.96. What is the ratio of the Rating (1=low 6=high) of Gender equality in 2006 to that in 2010?
Your answer should be compact. 0.99. What is the ratio of the Rating (1=low 6=high) of Social Protection in 2006 to that in 2010?
Your answer should be very brief. 0.98. What is the ratio of the Rating (1=low 6=high) in Quality of public administration in 2006 to that in 2010?
Your answer should be compact. 0.96. What is the ratio of the Rating (1=low 6=high) of Public sector management in 2006 to that in 2010?
Offer a terse response. 0.94. What is the ratio of the Rating (1=low 6=high) in Social Protection in 2006 to that in 2011?
Keep it short and to the point. 1.05. What is the ratio of the Rating (1=low 6=high) in Quality of public administration in 2006 to that in 2011?
Your answer should be compact. 1.01. What is the ratio of the Rating (1=low 6=high) of Public sector management in 2006 to that in 2011?
Offer a terse response. 0.95. What is the ratio of the Rating (1=low 6=high) in Gender equality in 2006 to that in 2012?
Offer a terse response. 1.01. What is the ratio of the Rating (1=low 6=high) of Social Protection in 2006 to that in 2012?
Ensure brevity in your answer.  1.06. What is the ratio of the Rating (1=low 6=high) in Quality of public administration in 2006 to that in 2012?
Keep it short and to the point. 1.02. What is the ratio of the Rating (1=low 6=high) in Public sector management in 2006 to that in 2012?
Provide a short and direct response. 0.96. What is the ratio of the Rating (1=low 6=high) of Social Protection in 2007 to that in 2008?
Give a very brief answer. 0.98. What is the ratio of the Rating (1=low 6=high) in Quality of public administration in 2007 to that in 2008?
Provide a short and direct response. 0.97. What is the ratio of the Rating (1=low 6=high) of Public sector management in 2007 to that in 2008?
Offer a terse response. 0.97. What is the ratio of the Rating (1=low 6=high) in Gender equality in 2007 to that in 2009?
Your answer should be compact. 1. What is the ratio of the Rating (1=low 6=high) in Social Protection in 2007 to that in 2009?
Your answer should be compact. 0.98. What is the ratio of the Rating (1=low 6=high) in Quality of public administration in 2007 to that in 2009?
Give a very brief answer. 0.97. What is the ratio of the Rating (1=low 6=high) of Public sector management in 2007 to that in 2009?
Ensure brevity in your answer.  0.96. What is the ratio of the Rating (1=low 6=high) in Social Protection in 2007 to that in 2010?
Ensure brevity in your answer.  0.97. What is the ratio of the Rating (1=low 6=high) in Quality of public administration in 2007 to that in 2010?
Keep it short and to the point. 0.96. What is the ratio of the Rating (1=low 6=high) of Public sector management in 2007 to that in 2010?
Ensure brevity in your answer.  0.94. What is the ratio of the Rating (1=low 6=high) in Gender equality in 2007 to that in 2011?
Provide a succinct answer. 1.02. What is the ratio of the Rating (1=low 6=high) of Social Protection in 2007 to that in 2011?
Provide a succinct answer. 1.03. What is the ratio of the Rating (1=low 6=high) in Quality of public administration in 2007 to that in 2011?
Offer a terse response. 1.01. What is the ratio of the Rating (1=low 6=high) in Public sector management in 2007 to that in 2011?
Give a very brief answer. 0.96. What is the ratio of the Rating (1=low 6=high) of Gender equality in 2007 to that in 2012?
Offer a very short reply. 1.02. What is the ratio of the Rating (1=low 6=high) of Social Protection in 2007 to that in 2012?
Your response must be concise. 1.04. What is the ratio of the Rating (1=low 6=high) in Quality of public administration in 2007 to that in 2012?
Give a very brief answer. 1.02. What is the ratio of the Rating (1=low 6=high) of Public sector management in 2007 to that in 2012?
Offer a very short reply. 0.96. What is the ratio of the Rating (1=low 6=high) of Social Protection in 2008 to that in 2009?
Provide a succinct answer. 1. What is the ratio of the Rating (1=low 6=high) of Public sector management in 2008 to that in 2009?
Provide a succinct answer. 0.99. What is the ratio of the Rating (1=low 6=high) of Social Protection in 2008 to that in 2010?
Your response must be concise. 0.98. What is the ratio of the Rating (1=low 6=high) in Quality of public administration in 2008 to that in 2010?
Your answer should be very brief. 0.99. What is the ratio of the Rating (1=low 6=high) in Public sector management in 2008 to that in 2010?
Ensure brevity in your answer.  0.97. What is the ratio of the Rating (1=low 6=high) of Gender equality in 2008 to that in 2011?
Provide a short and direct response. 1.02. What is the ratio of the Rating (1=low 6=high) in Social Protection in 2008 to that in 2011?
Give a very brief answer. 1.05. What is the ratio of the Rating (1=low 6=high) of Public sector management in 2008 to that in 2011?
Offer a very short reply. 0.98. What is the ratio of the Rating (1=low 6=high) of Gender equality in 2008 to that in 2012?
Offer a very short reply. 1.02. What is the ratio of the Rating (1=low 6=high) of Social Protection in 2008 to that in 2012?
Ensure brevity in your answer.  1.06. What is the ratio of the Rating (1=low 6=high) of Quality of public administration in 2008 to that in 2012?
Your answer should be very brief. 1.05. What is the ratio of the Rating (1=low 6=high) of Public sector management in 2008 to that in 2012?
Provide a succinct answer. 0.99. What is the ratio of the Rating (1=low 6=high) of Social Protection in 2009 to that in 2010?
Your answer should be compact. 0.98. What is the ratio of the Rating (1=low 6=high) of Quality of public administration in 2009 to that in 2010?
Provide a succinct answer. 0.99. What is the ratio of the Rating (1=low 6=high) of Public sector management in 2009 to that in 2010?
Offer a terse response. 0.98. What is the ratio of the Rating (1=low 6=high) in Gender equality in 2009 to that in 2011?
Make the answer very short. 1.02. What is the ratio of the Rating (1=low 6=high) of Social Protection in 2009 to that in 2011?
Offer a very short reply. 1.05. What is the ratio of the Rating (1=low 6=high) in Gender equality in 2009 to that in 2012?
Offer a very short reply. 1.02. What is the ratio of the Rating (1=low 6=high) in Social Protection in 2009 to that in 2012?
Make the answer very short. 1.06. What is the ratio of the Rating (1=low 6=high) of Public sector management in 2009 to that in 2012?
Offer a terse response. 1. What is the ratio of the Rating (1=low 6=high) in Gender equality in 2010 to that in 2011?
Make the answer very short. 1.02. What is the ratio of the Rating (1=low 6=high) in Social Protection in 2010 to that in 2011?
Give a very brief answer. 1.07. What is the ratio of the Rating (1=low 6=high) of Quality of public administration in 2010 to that in 2011?
Your response must be concise. 1.06. What is the ratio of the Rating (1=low 6=high) of Gender equality in 2010 to that in 2012?
Your answer should be very brief. 1.02. What is the ratio of the Rating (1=low 6=high) in Social Protection in 2010 to that in 2012?
Your answer should be very brief. 1.07. What is the ratio of the Rating (1=low 6=high) in Quality of public administration in 2010 to that in 2012?
Provide a succinct answer. 1.07. What is the ratio of the Rating (1=low 6=high) of Public sector management in 2010 to that in 2012?
Offer a very short reply. 1.02. What is the ratio of the Rating (1=low 6=high) of Gender equality in 2011 to that in 2012?
Offer a very short reply. 1.01. What is the ratio of the Rating (1=low 6=high) of Social Protection in 2011 to that in 2012?
Provide a short and direct response. 1.01. What is the ratio of the Rating (1=low 6=high) of Quality of public administration in 2011 to that in 2012?
Give a very brief answer. 1.01. What is the difference between the highest and the second highest Rating (1=low 6=high) in Gender equality?
Make the answer very short. 0. What is the difference between the highest and the second highest Rating (1=low 6=high) of Social Protection?
Make the answer very short. 0.05. What is the difference between the highest and the second highest Rating (1=low 6=high) of Quality of public administration?
Provide a succinct answer. 0.05. What is the difference between the highest and the second highest Rating (1=low 6=high) in Public sector management?
Make the answer very short. 0.04. What is the difference between the highest and the lowest Rating (1=low 6=high) of Gender equality?
Offer a very short reply. 0.08. What is the difference between the highest and the lowest Rating (1=low 6=high) in Social Protection?
Your response must be concise. 0.2. What is the difference between the highest and the lowest Rating (1=low 6=high) in Quality of public administration?
Give a very brief answer. 0.19. What is the difference between the highest and the lowest Rating (1=low 6=high) of Public sector management?
Give a very brief answer. 0.19. 